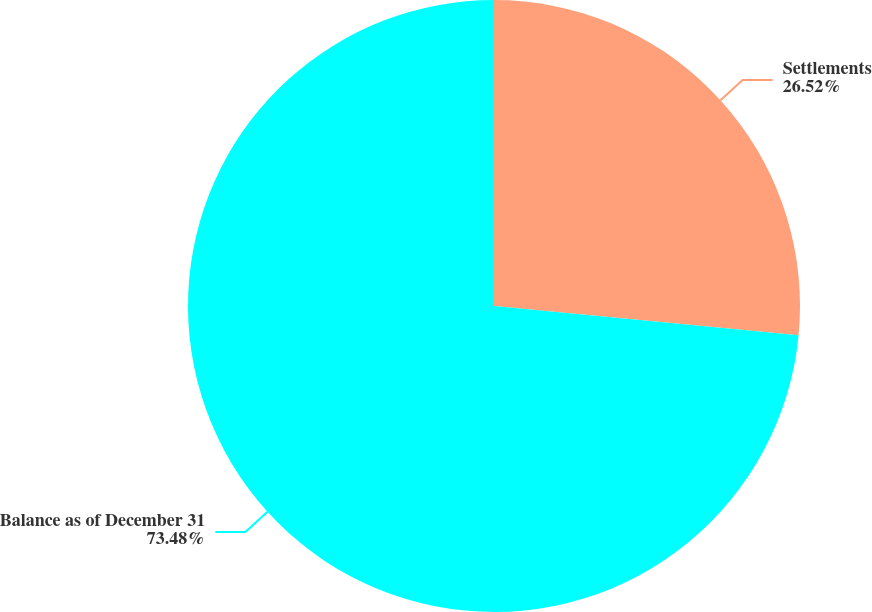<chart> <loc_0><loc_0><loc_500><loc_500><pie_chart><fcel>Settlements<fcel>Balance as of December 31<nl><fcel>26.52%<fcel>73.48%<nl></chart> 